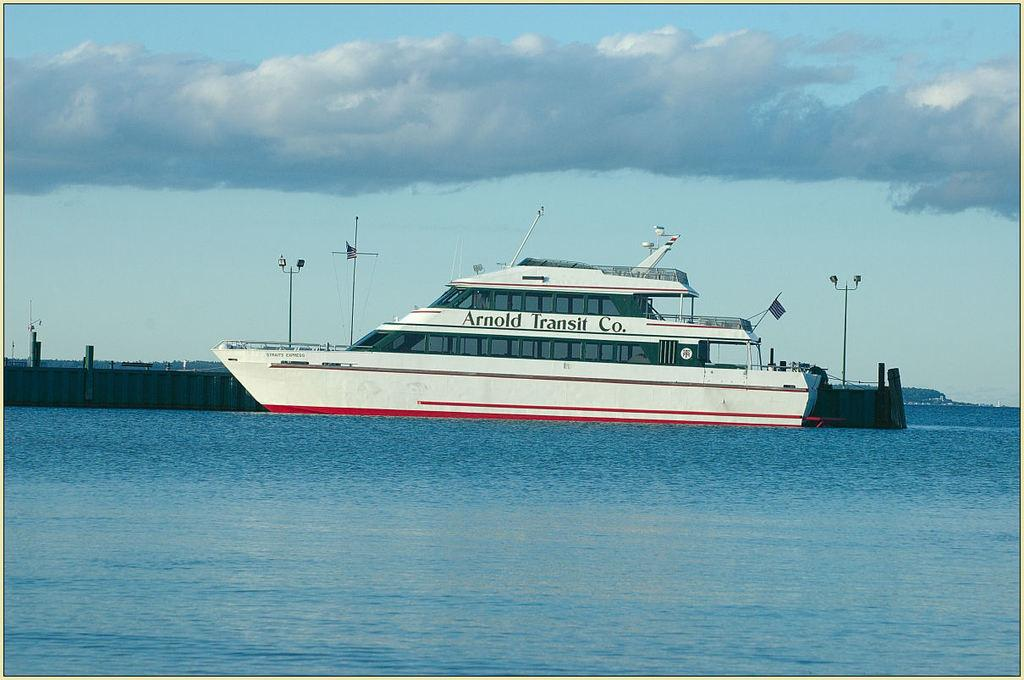What is the main subject of the image? There is a ship in the image. Where is the ship located? The ship is on a river. What can be seen behind the ship? There is a railing and poles behind the ship. What natural features are visible in the image? Mountains and the sky are visible in the image. Can you tell me how many bananas are hanging from the railing behind the ship? There are no bananas present in the image; the railing is behind the ship on a river. 